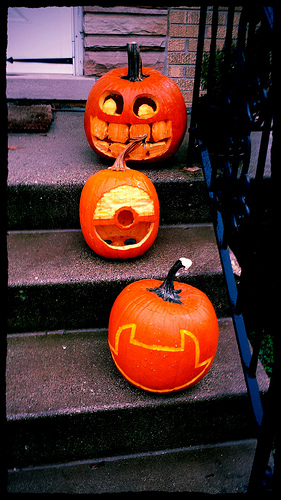<image>
Is the pumpkin on the stairs? Yes. Looking at the image, I can see the pumpkin is positioned on top of the stairs, with the stairs providing support. Where is the pumpkin in relation to the stairs? Is it on the stairs? Yes. Looking at the image, I can see the pumpkin is positioned on top of the stairs, with the stairs providing support. 